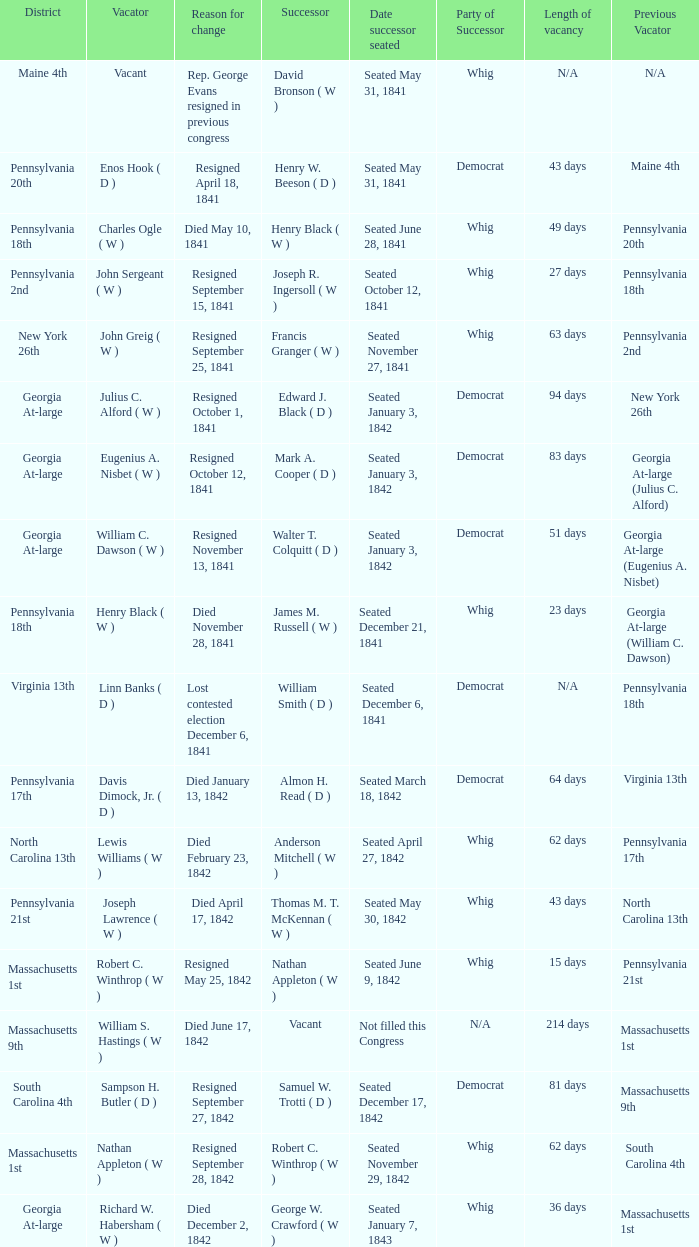Name the successor for north carolina 13th Anderson Mitchell ( W ). 